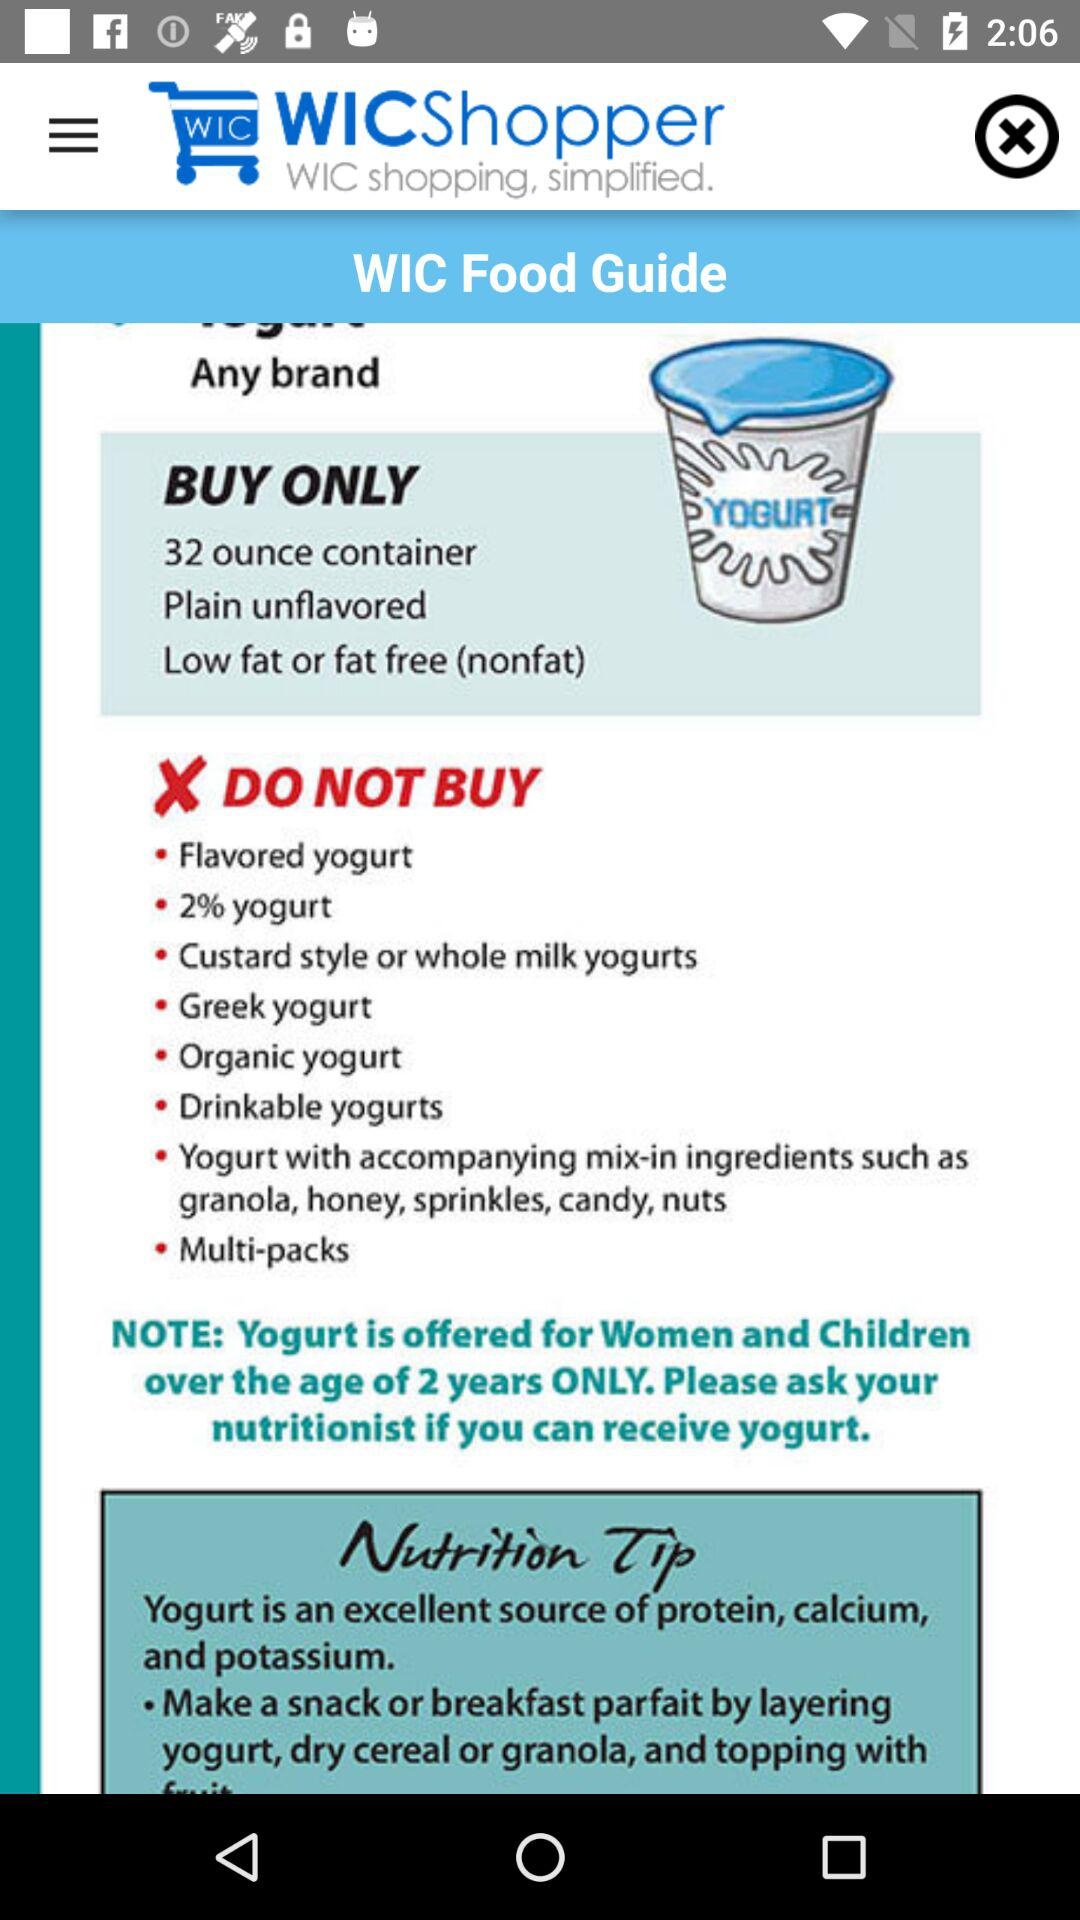What kind of yogurt only needs to be bought? The yogurt that only needs to be bought is in a 32-ounce container, plain and unflavored, and low-fat or fat-free (nonfat). 